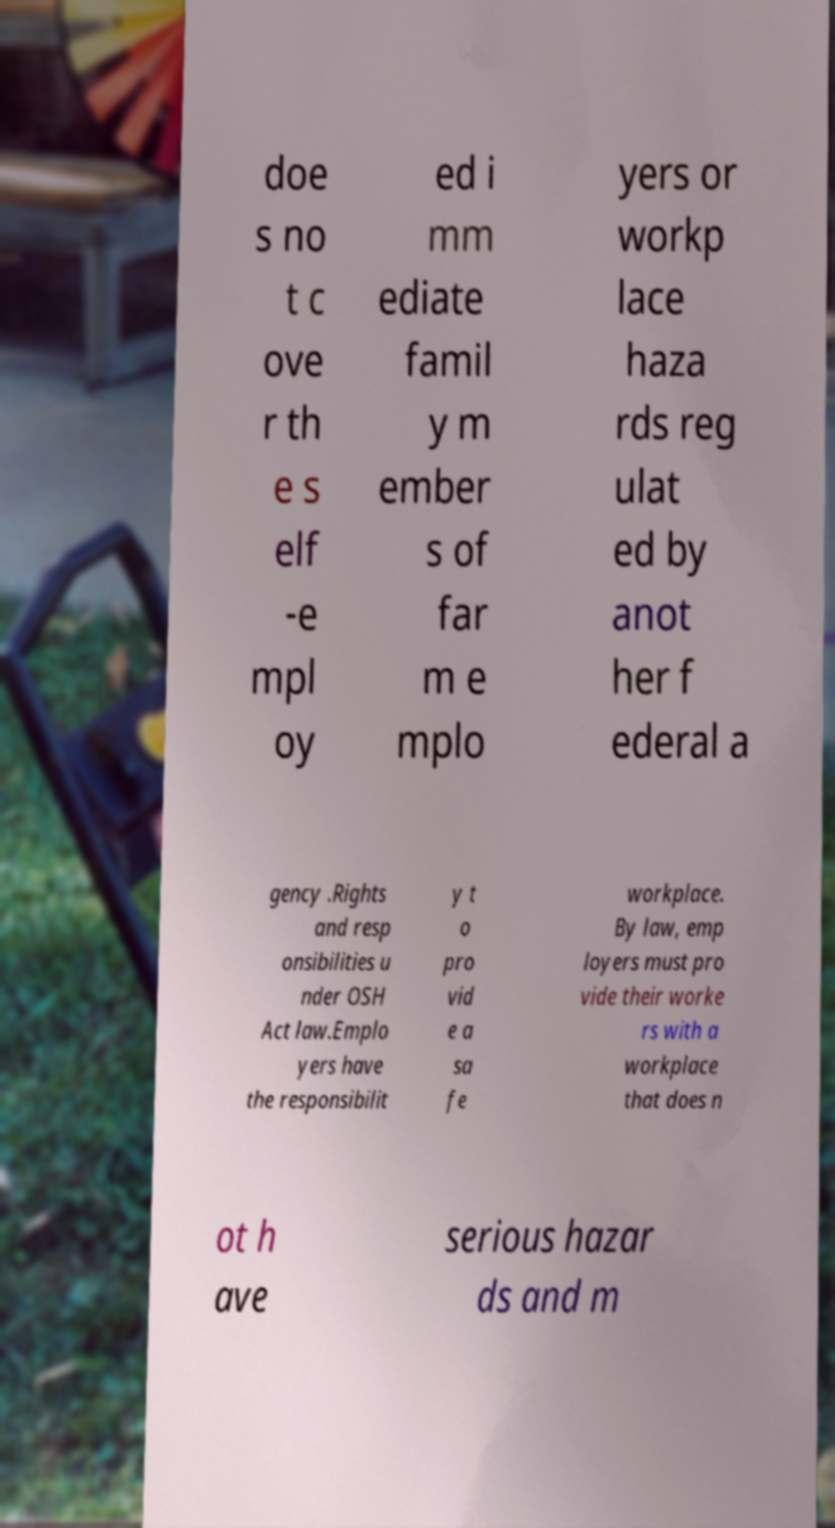Please read and relay the text visible in this image. What does it say? doe s no t c ove r th e s elf -e mpl oy ed i mm ediate famil y m ember s of far m e mplo yers or workp lace haza rds reg ulat ed by anot her f ederal a gency .Rights and resp onsibilities u nder OSH Act law.Emplo yers have the responsibilit y t o pro vid e a sa fe workplace. By law, emp loyers must pro vide their worke rs with a workplace that does n ot h ave serious hazar ds and m 